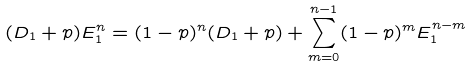<formula> <loc_0><loc_0><loc_500><loc_500>( D _ { 1 } + p ) E _ { 1 } ^ { n } = ( 1 - p ) ^ { n } ( D _ { 1 } + p ) + \sum _ { m = 0 } ^ { n - 1 } ( 1 - p ) ^ { m } E _ { 1 } ^ { n - m }</formula> 